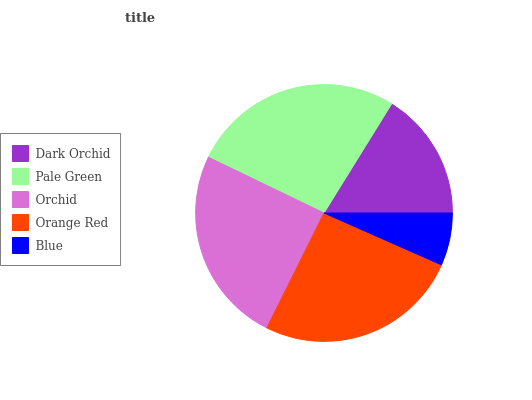Is Blue the minimum?
Answer yes or no. Yes. Is Pale Green the maximum?
Answer yes or no. Yes. Is Orchid the minimum?
Answer yes or no. No. Is Orchid the maximum?
Answer yes or no. No. Is Pale Green greater than Orchid?
Answer yes or no. Yes. Is Orchid less than Pale Green?
Answer yes or no. Yes. Is Orchid greater than Pale Green?
Answer yes or no. No. Is Pale Green less than Orchid?
Answer yes or no. No. Is Orchid the high median?
Answer yes or no. Yes. Is Orchid the low median?
Answer yes or no. Yes. Is Blue the high median?
Answer yes or no. No. Is Pale Green the low median?
Answer yes or no. No. 